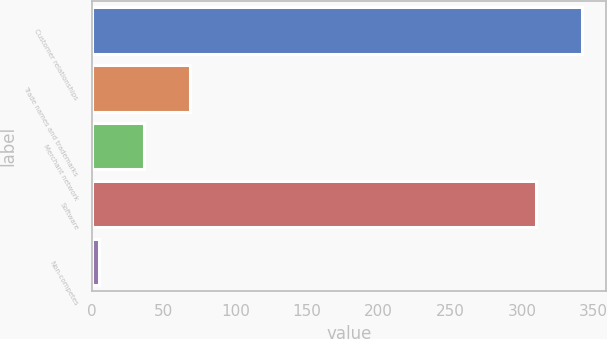Convert chart. <chart><loc_0><loc_0><loc_500><loc_500><bar_chart><fcel>Customer relationships<fcel>Trade names and trademarks<fcel>Merchant network<fcel>Software<fcel>Non-competes<nl><fcel>341.5<fcel>68<fcel>36.5<fcel>310<fcel>5<nl></chart> 